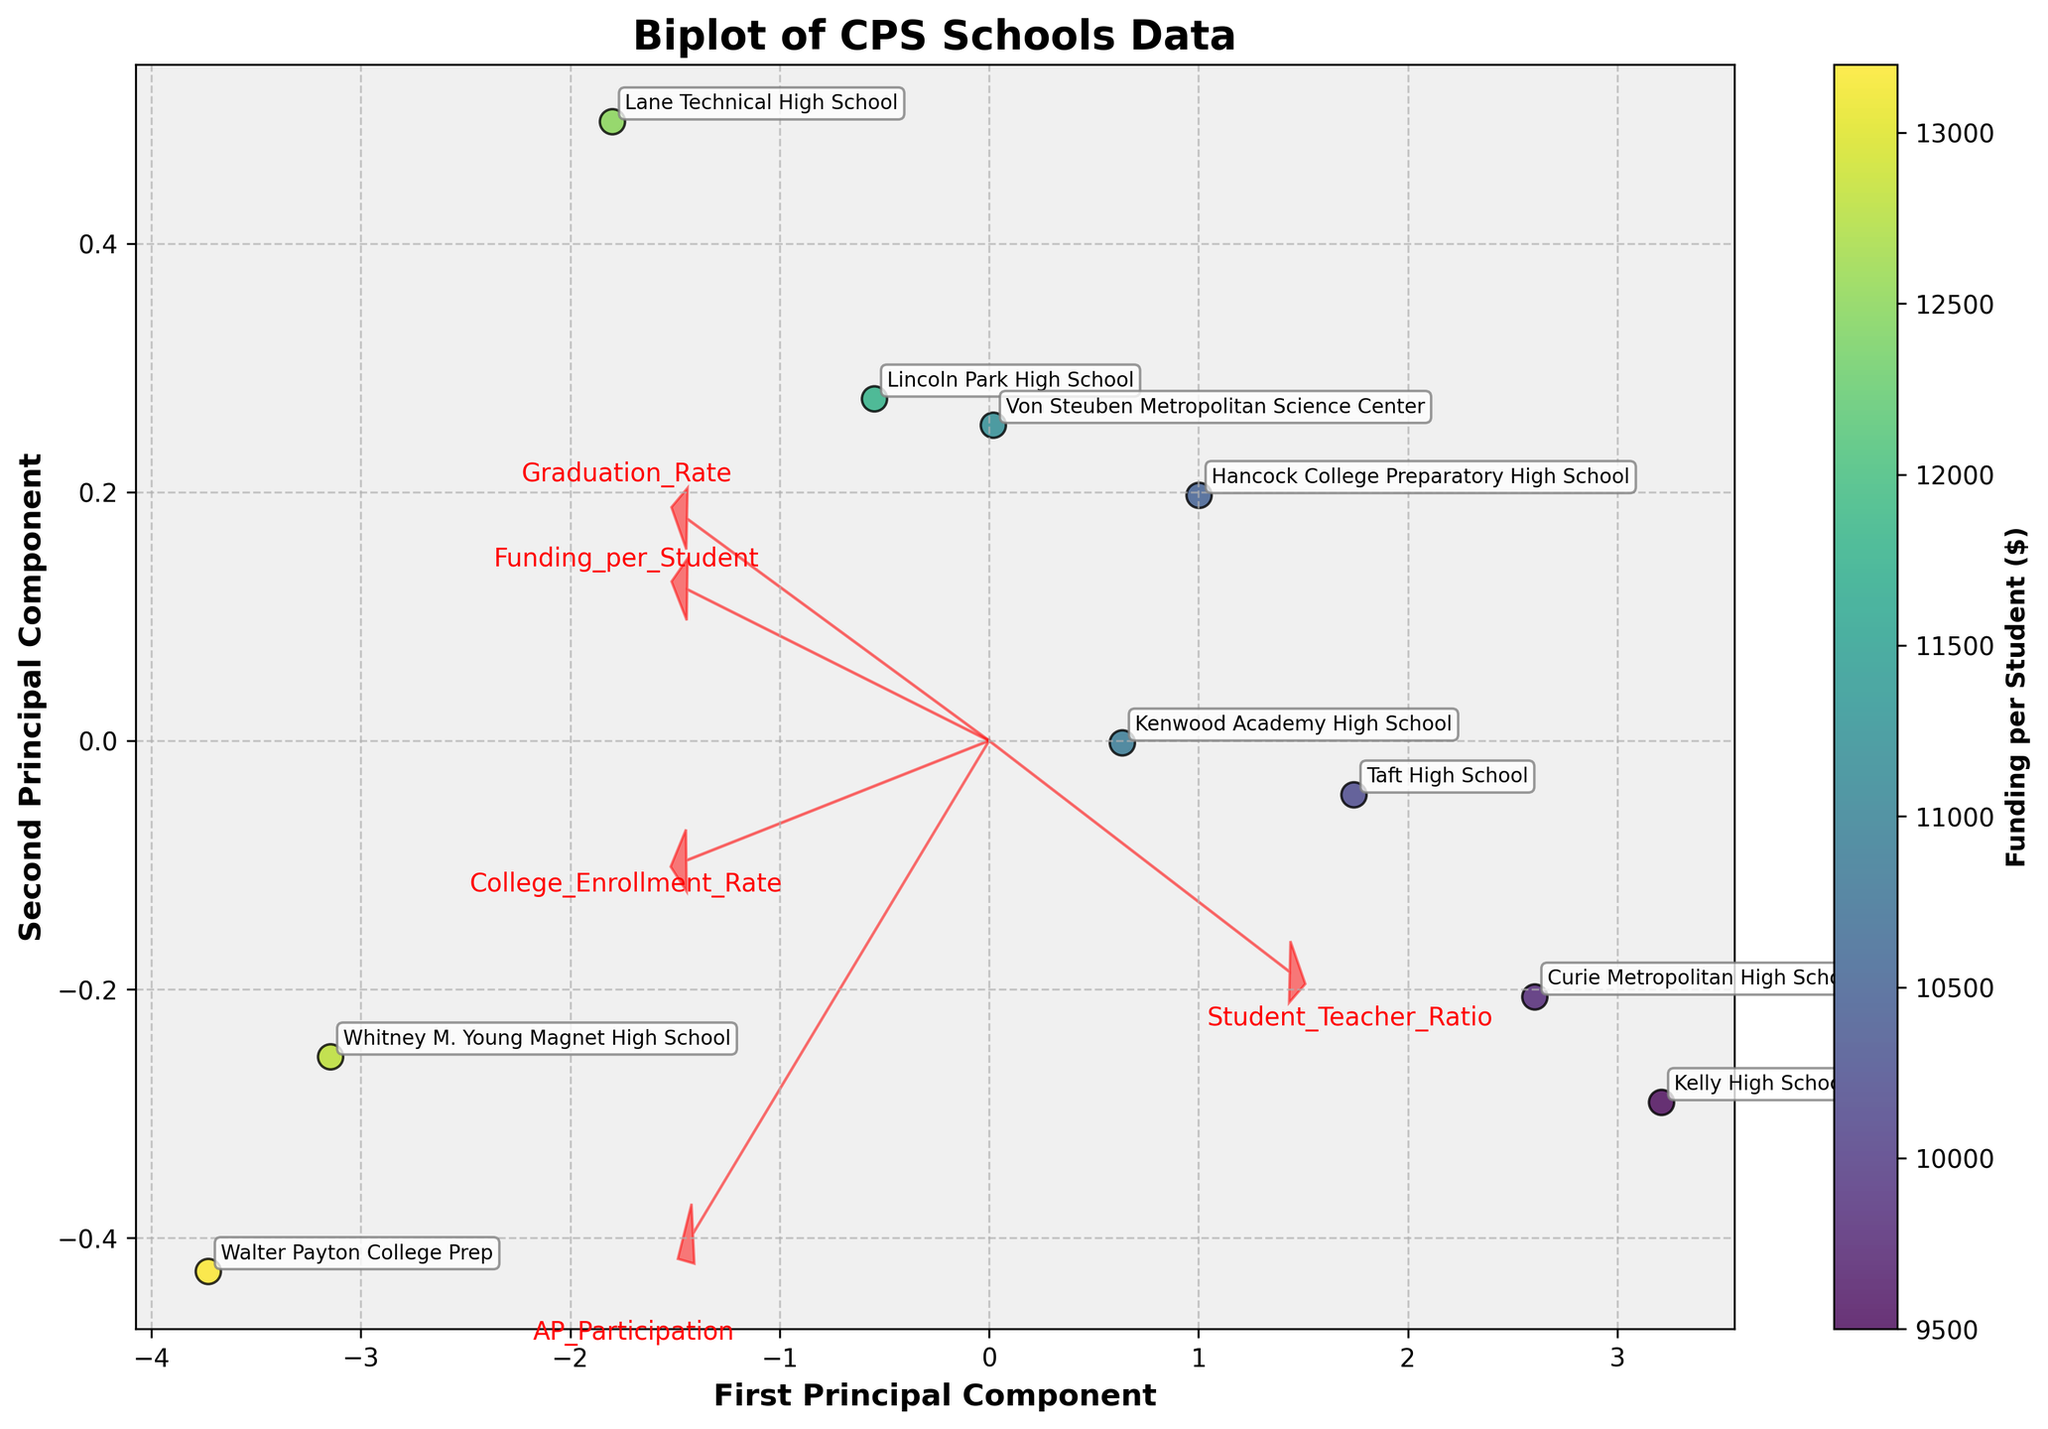What does the title of the biplot say? The title of the plot is displayed at the top, typically in bold or larger font compared to other text, indicating what the figure is about.
Answer: Biplot of CPS Schools Data What do the x and y axes represent in this biplot? The x and y axes are labeled at the bottom and on the left side of the plot, indicating the variables represented by each principal component.
Answer: First Principal Component and Second Principal Component How many data points are shown on the biplot? Each data point corresponds to a school, represented by a point within the plot area. One can count the number of these points to determine the total.
Answer: 10 Which school has the highest funding per student? By looking at the color gradient on the biplot, we can identify the school with the highest value in the colorbar. Annotated school names help in pinpointing exact schools.
Answer: Walter Payton College Prep Which feature has the longest arrow vector in the plot? The arrows represent different features, and their lengths indicate the variance each feature contributes to the principal components. The longest arrow vector can be identified visually.
Answer: AP Participation Is there a correlation between 'Graduation Rate' and 'College Enrollment Rate' according to the biplot? Features close together in the biplot indicate a positive correlation. By examining the directions of the arrows for both 'Graduation Rate' and 'College Enrollment Rate', we can assess the correlation.
Answer: Yes How does 'Funding per Student' affect the placement of schools on the plot? Schools with different 'Funding per Student' levels are color-coded. Observing the color gradient distribution helps determine the influence of funding on the schools' positions.
Answer: Schools with higher funding tend to be grouped together Which school has the lowest 'Graduation Rate' and where is it located on the biplot? By looking at the annotations and cross-referencing with the 'Graduation Rate' values, the school with the lowest rate can be found on the biplot's coordinate plane.
Answer: Kelly High School Compare the 'Student Teacher Ratio' vector to other vectors. Is it positively or negatively correlated with 'Funding per Student'? By comparing the direction of the 'Student Teacher Ratio' vector with the 'Funding per Student' vector (indicated by color gradient), the correlation can be deduced.
Answer: Negatively correlated Do schools with higher 'AP Participation' tend to have a higher 'College Enrollment Rate'? Observing the directions and lengths of the arrows for 'AP Participation' and 'College Enrollment Rate' can help identify whether these features are positively correlated.
Answer: Yes 